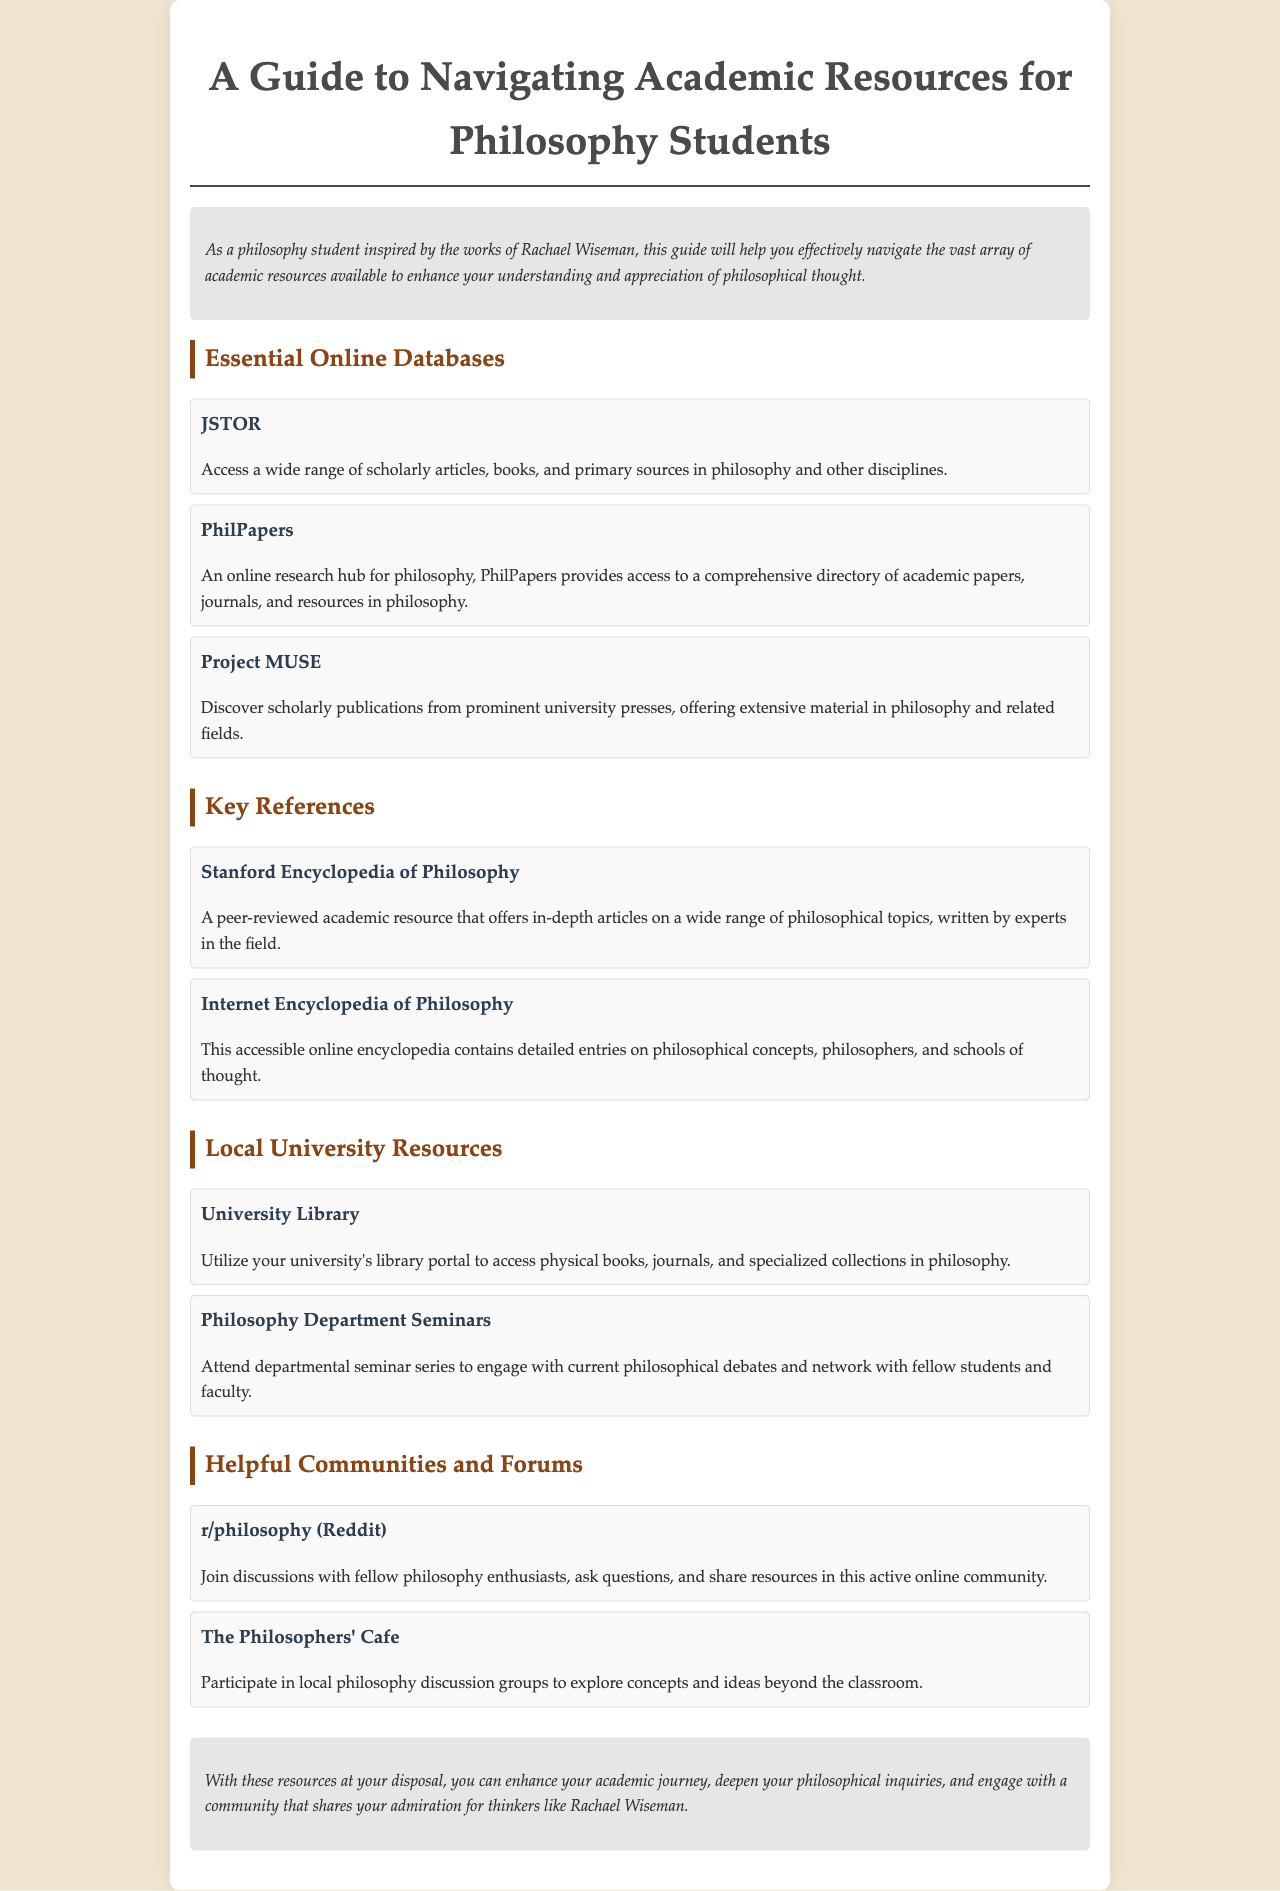What is the title of the guide? The title of the guide is clearly stated at the top of the document.
Answer: A Guide to Navigating Academic Resources for Philosophy Students Who is one of the key references listed in the document? This information can be found in the "Key References" section, which lists significant philosophical resources.
Answer: Stanford Encyclopedia of Philosophy What online database provides access to a comprehensive directory of academic papers in philosophy? This is mentioned in the "Essential Online Databases" section, highlighting a specific resource for research.
Answer: PhilPapers What type of resource is the University Library classified as? The University Library is mentioned under the "Local University Resources" section, indicating its purpose.
Answer: Local University Resource Name one community mentioned for philosophy discussions. This information is found in the "Helpful Communities and Forums" section, listing platforms for discussions.
Answer: r/philosophy (Reddit) How many online databases are listed in the document? The count of online databases is derived by counting the entries under the "Essential Online Databases" section.
Answer: Three What is emphasized in the conclusion of the document? The conclusion summarizes the importance of the resources provided, indicating their role in the academic journey.
Answer: Enhancing academic journey What is the background color of the brochure's body? This detail pertains to the visual design aspect, which can be inferred from the document's style.
Answer: #f0e6d2 